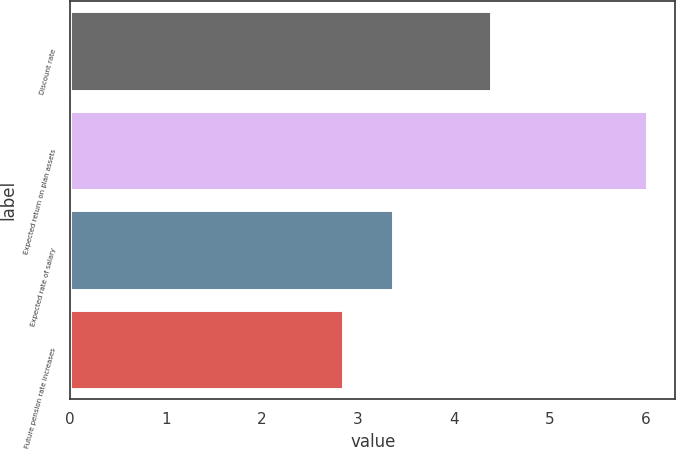Convert chart to OTSL. <chart><loc_0><loc_0><loc_500><loc_500><bar_chart><fcel>Discount rate<fcel>Expected return on plan assets<fcel>Expected rate of salary<fcel>Future pension rate increases<nl><fcel>4.39<fcel>6.01<fcel>3.37<fcel>2.85<nl></chart> 